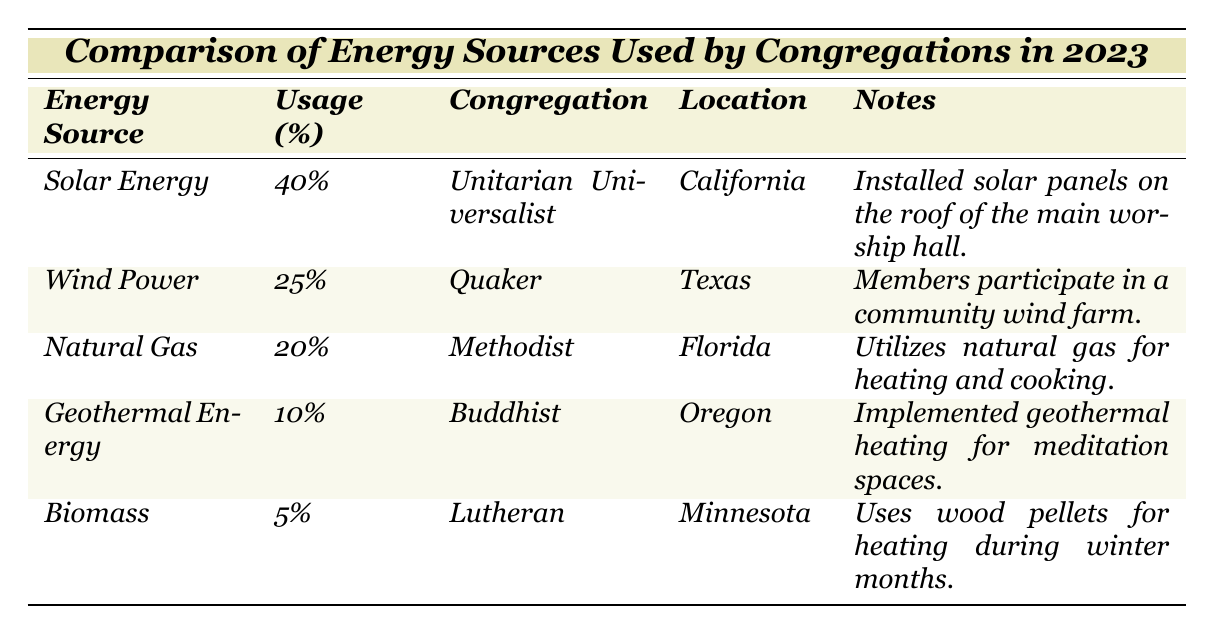What is the most commonly used energy source among the congregations? According to the table, solar energy is listed with a usage percentage of 40%, which is the highest compared to the other energy sources.
Answer: Solar Energy Which congregation uses wind power, and what is its location? The table indicates that the Quaker congregation uses wind power, and it is located in Texas.
Answer: Quaker, Texas What percentage of congregations' energy comes from biomass? The table shows that biomass contributes 5% to the energy consumption of the congregations.
Answer: 5% If we add the percentages of solar and wind power, what is the total percentage? The percentage of solar energy is 40%, and wind power is 25%. Adding these together (40% + 25%) gives 65%.
Answer: 65% Is it true that more congregations use geothermal energy than biomass? The table shows that 10% of the energy comes from geothermal energy and only 5% from biomass, so yes, it is true.
Answer: Yes Which type of congregation uses natural gas, and what specific uses does it have? The Methodist congregation uses natural gas, specifically for heating and cooking, as stated in the notes of the table.
Answer: Methodist, for heating and cooking What is the difference in percentage of energy usage between solar energy and geothermal energy? Solar energy usage is 40%, and geothermal energy usage is 10%. The difference is (40% - 10%) = 30%.
Answer: 30% What would the average energy usage percentage be if the biomass percentage was excluded? The percentages of the remaining energy sources are 40% (solar), 25% (wind), 20% (natural gas), and 10% (geothermal), totaling 95%. Dividing by 4 (the number of sources) gives an average of 23.75%.
Answer: 23.75% Which congregation has the lowest energy source usage, and what is that percentage? The table indicates that biomass has the lowest percentage of usage at 5%, and it is used by the Lutheran congregation.
Answer: Lutheran, 5% If a congregation's worship hall was to use 50% solar energy and 50% wind power, what would be a comparable energy strategy to the data in the table? A comparable strategy would be to install solar panels similar to the Unitarian Universalist congregation, which uses solar energy extensively.
Answer: Install solar panels 